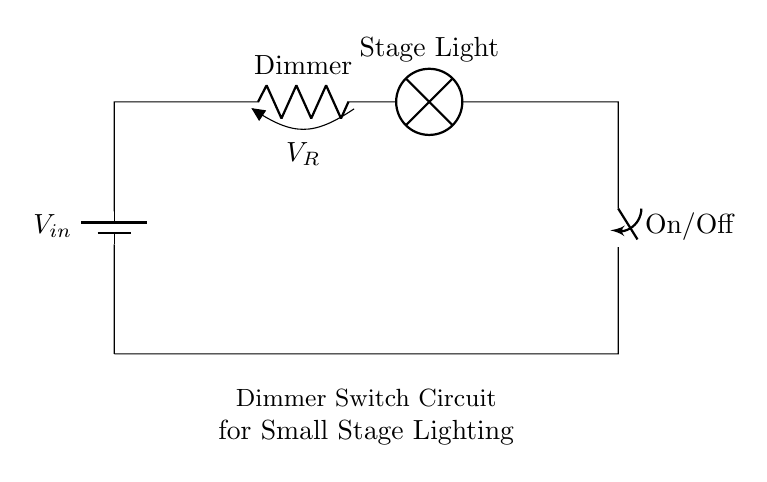What is the input voltage in this circuit? The input voltage is labeled as V_in, which is the voltage source connected at the top left of the circuit diagram. It typically provides the power for the entire circuit.
Answer: V_in What component controls the brightness of the stage light? The component that controls the brightness is the Dimmer, which is represented by the resistor in the circuit. Its resistance can be varied, affecting the voltage drop and, thus, the brightness of the light.
Answer: Dimmer What is the function of the switch in the circuit? The switch is labeled On/Off and serves to either complete or break the circuit. When the switch is in the 'On' position, current flows through the circuit; when 'Off', it interrupts the current, turning off the light.
Answer: On/Off How many components are in series in this circuit? In this series circuit, all components are connected one after another without any branching. The components include the battery, Dimmer, stage light, and switch, so there are four components in series.
Answer: Four What happens to the current if the Dimmer resistance increases? If the Dimmer resistance increases, it creates a higher voltage drop across the Dimmer, resulting in less voltage available for the stage light. Consequently, the current through the circuit decreases, dimming the light further.
Answer: Decreases Is the circuit designed for alternating or direct current? The circuit diagram implies the use of a battery, indicating that it is designed for direct current, where the flow of electrons is in a constant direction.
Answer: Direct current 